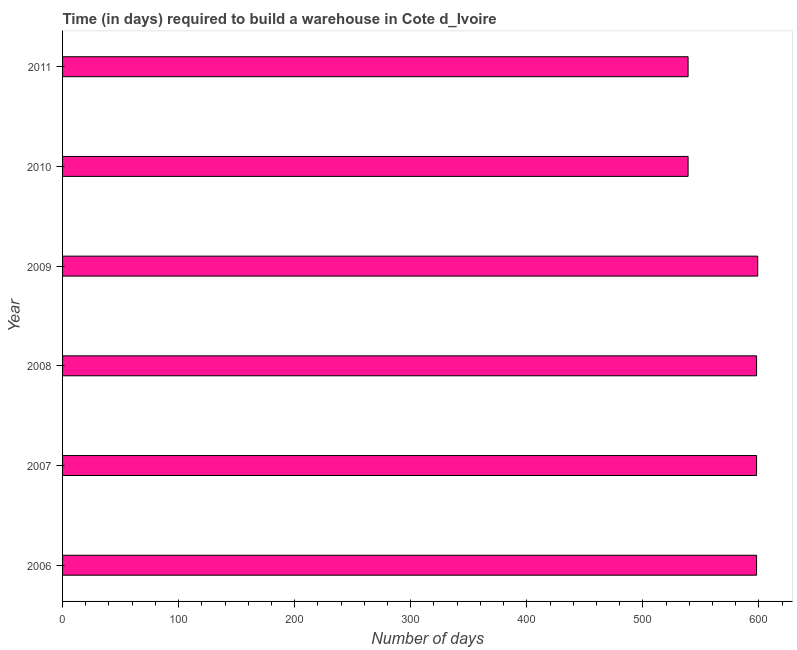What is the title of the graph?
Your answer should be very brief. Time (in days) required to build a warehouse in Cote d_Ivoire. What is the label or title of the X-axis?
Provide a succinct answer. Number of days. What is the label or title of the Y-axis?
Your answer should be very brief. Year. What is the time required to build a warehouse in 2010?
Provide a short and direct response. 539. Across all years, what is the maximum time required to build a warehouse?
Your answer should be very brief. 599. Across all years, what is the minimum time required to build a warehouse?
Provide a short and direct response. 539. In which year was the time required to build a warehouse maximum?
Provide a short and direct response. 2009. What is the sum of the time required to build a warehouse?
Make the answer very short. 3471. What is the difference between the time required to build a warehouse in 2009 and 2011?
Give a very brief answer. 60. What is the average time required to build a warehouse per year?
Make the answer very short. 578. What is the median time required to build a warehouse?
Give a very brief answer. 598. In how many years, is the time required to build a warehouse greater than 220 days?
Keep it short and to the point. 6. Do a majority of the years between 2009 and 2011 (inclusive) have time required to build a warehouse greater than 100 days?
Provide a succinct answer. Yes. What is the ratio of the time required to build a warehouse in 2008 to that in 2010?
Offer a terse response. 1.11. Is the time required to build a warehouse in 2006 less than that in 2009?
Offer a terse response. Yes. Is the difference between the time required to build a warehouse in 2006 and 2007 greater than the difference between any two years?
Keep it short and to the point. No. Is the sum of the time required to build a warehouse in 2007 and 2008 greater than the maximum time required to build a warehouse across all years?
Offer a very short reply. Yes. What is the difference between the highest and the lowest time required to build a warehouse?
Give a very brief answer. 60. Are all the bars in the graph horizontal?
Offer a terse response. Yes. How many years are there in the graph?
Provide a short and direct response. 6. What is the difference between two consecutive major ticks on the X-axis?
Give a very brief answer. 100. What is the Number of days of 2006?
Provide a succinct answer. 598. What is the Number of days of 2007?
Your answer should be compact. 598. What is the Number of days of 2008?
Keep it short and to the point. 598. What is the Number of days of 2009?
Provide a succinct answer. 599. What is the Number of days in 2010?
Provide a succinct answer. 539. What is the Number of days in 2011?
Your response must be concise. 539. What is the difference between the Number of days in 2006 and 2007?
Keep it short and to the point. 0. What is the difference between the Number of days in 2007 and 2008?
Give a very brief answer. 0. What is the difference between the Number of days in 2007 and 2009?
Offer a terse response. -1. What is the difference between the Number of days in 2007 and 2010?
Your answer should be compact. 59. What is the difference between the Number of days in 2008 and 2010?
Give a very brief answer. 59. What is the difference between the Number of days in 2010 and 2011?
Make the answer very short. 0. What is the ratio of the Number of days in 2006 to that in 2008?
Offer a terse response. 1. What is the ratio of the Number of days in 2006 to that in 2010?
Keep it short and to the point. 1.11. What is the ratio of the Number of days in 2006 to that in 2011?
Your answer should be very brief. 1.11. What is the ratio of the Number of days in 2007 to that in 2010?
Your answer should be compact. 1.11. What is the ratio of the Number of days in 2007 to that in 2011?
Provide a short and direct response. 1.11. What is the ratio of the Number of days in 2008 to that in 2010?
Your answer should be very brief. 1.11. What is the ratio of the Number of days in 2008 to that in 2011?
Provide a succinct answer. 1.11. What is the ratio of the Number of days in 2009 to that in 2010?
Give a very brief answer. 1.11. What is the ratio of the Number of days in 2009 to that in 2011?
Give a very brief answer. 1.11. 